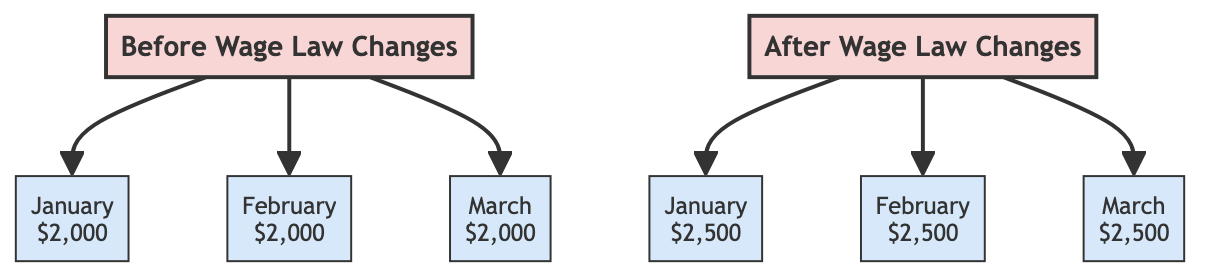What was the salary in January before the wage law changes? According to the diagram, the node corresponding to January before the wage law changes shows a salary of $2,000.
Answer: $2,000 How many months are displayed in the diagram? The diagram contains nodes for three months: January, February, and March, which are both before and after the wage law changes. Therefore, there are a total of six months displayed.
Answer: 6 What is the salary in February after the wage law changes? The February node after the wage law changes indicates a salary of $2,500.
Answer: $2,500 Which month shows a salary increase of $500? By comparing the before and after nodes, it is observed that the salary increased from $2,000 to $2,500 in each month, representing a $500 increase. This applies to all three months, hence the month can be any of them.
Answer: January, February, or March What is the difference in salary between before and after the wage law changes for March? In March, the salary increased from $2,000 before the changes to $2,500 after, which means the difference is $500.
Answer: $500 How many total salary values are represented in the diagram? Each month has two values (one before and one after), and there are three months represented. Thus, the total number of salary values is six.
Answer: 6 What does the diagram primarily compare? The diagram compares the monthly salaries before and after the wage law changes, depicted through the separate categories for each timeframe.
Answer: Monthly salaries What type of diagram is used to compare the data? The diagram is a flowchart, as indicated by its structure and the use of categories to separate the before and after conditions regarding the wage law.
Answer: Flowchart 